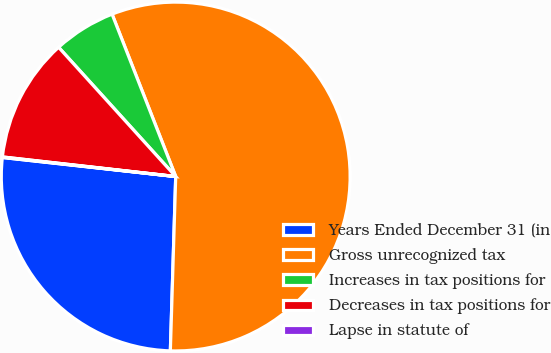Convert chart to OTSL. <chart><loc_0><loc_0><loc_500><loc_500><pie_chart><fcel>Years Ended December 31 (in<fcel>Gross unrecognized tax<fcel>Increases in tax positions for<fcel>Decreases in tax positions for<fcel>Lapse in statute of<nl><fcel>26.25%<fcel>56.43%<fcel>5.77%<fcel>11.49%<fcel>0.05%<nl></chart> 